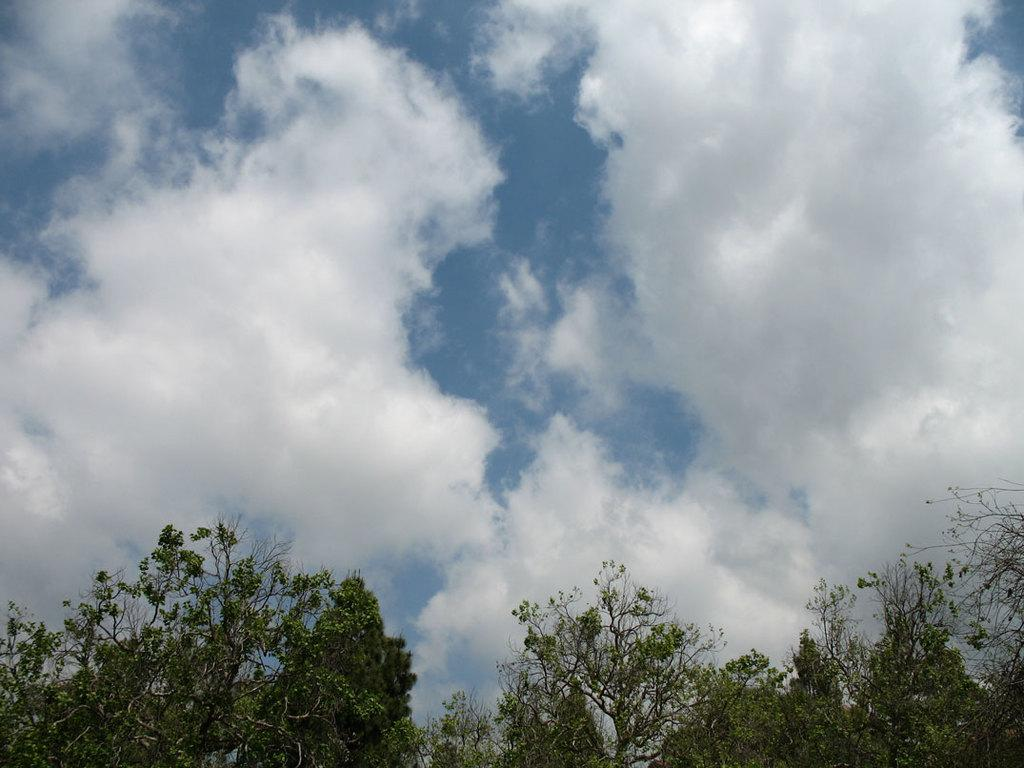What type of vegetation is present in the image? There are trees with green leaves in the image. What can be seen in the sky in the background of the image? There are clouds in the sky in the background of the image. What type of iron is used to create the collar on the tree in the image? There is no iron or collar present on the trees in the image; they have green leaves. 